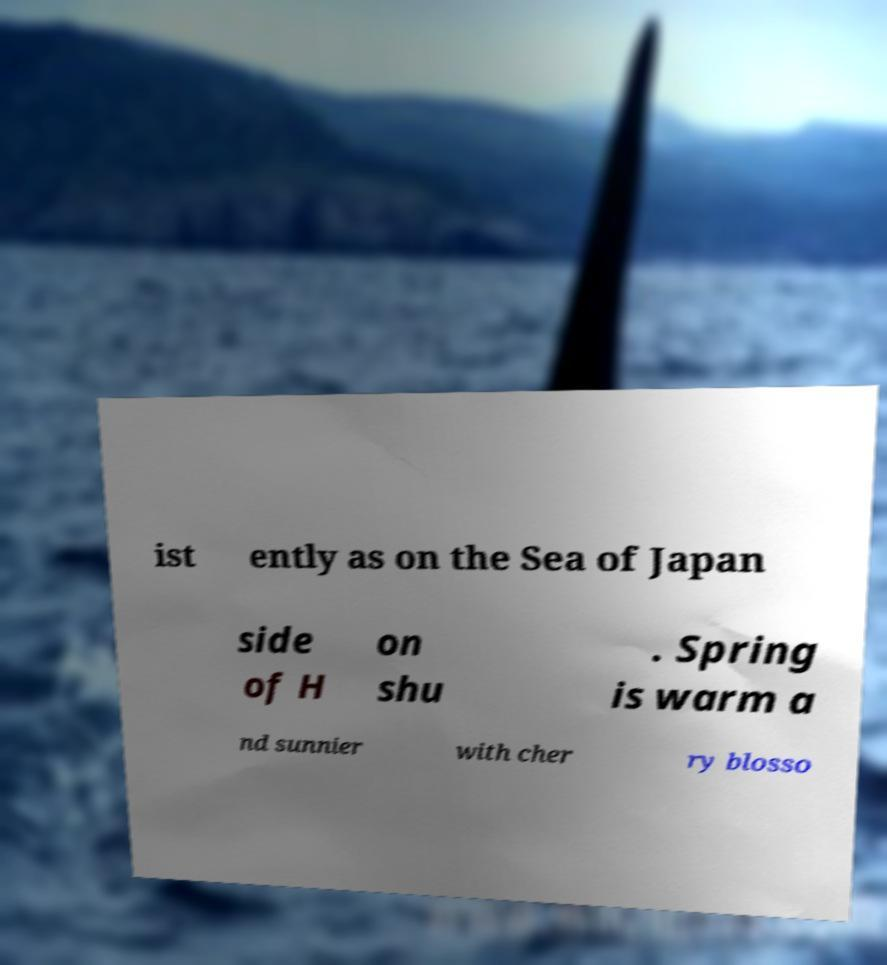Please identify and transcribe the text found in this image. ist ently as on the Sea of Japan side of H on shu . Spring is warm a nd sunnier with cher ry blosso 